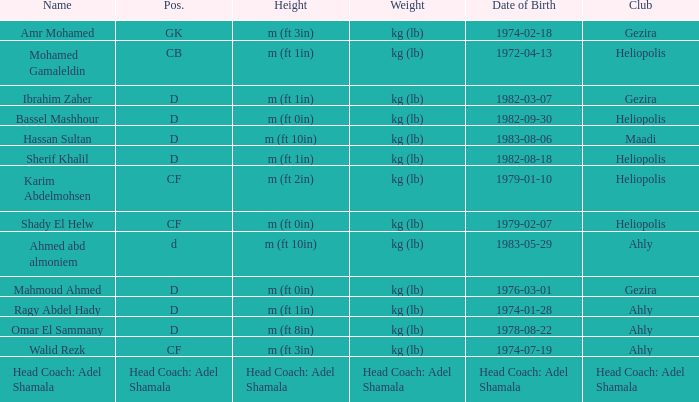What is the mass, when association is "ahly", and when moniker is "ragy abdel hady"? Kg (lb). 